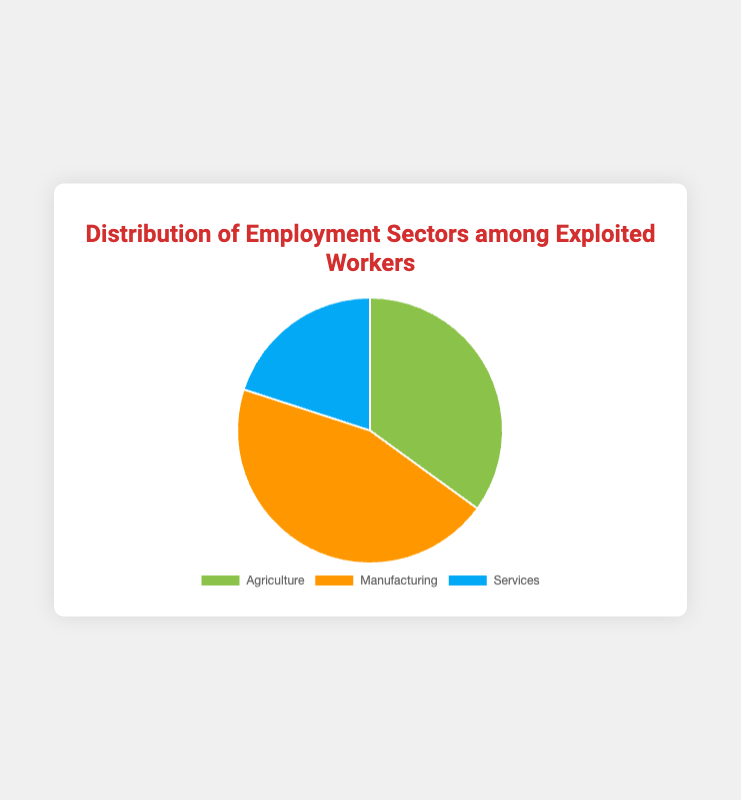What proportion of the workers are in Manufacturing? The pie chart shows 45% of the workers are in the Manufacturing sector.
Answer: 45% How does the proportion of workers in Agriculture compare to those in Services? The chart shows that Agriculture has 35% of workers, whereas Services has 20%. Therefore, Agriculture has 15% more workers than Services.
Answer: Agriculture has 15% more workers than Services What's the combined percentage of workers in Agriculture and Services? The chart shows Agriculture has 35% and Services have 20%. Adding these percentages gives 35% + 20% = 55%.
Answer: 55% Which sector employs the fewest workers? The chart indicates that Services have only 20% of the workers, which is the smallest proportion among the three sectors.
Answer: Services If we combine the percentages of Agriculture and Manufacturing, how does that compare to Services? Agriculture has 35% and Manufacturing has 45%, which adds up to 80%. This is 60% more than the 20% of Services.
Answer: 60% more What color represents the Agriculture sector in the pie chart? The Agriculture sector is represented by the green slice in the chart.
Answer: Green Which sector employs a smaller percentage of workers compared to Agriculture but more compared to Services? The Manufacturing sector has 45%, which is less than Agriculture's 35% but more than Services' 20%.
Answer: Manufacturing What is the difference in employment percentages between the Manufacturing and Services sectors? The Manufacturing sector has 45% of the workers while Services have 20%. The difference is 45% - 20% = 25%.
Answer: 25% If each percentage in the pie chart represents 10 workers, how many workers are in the Manufacturing sector? Each percent represents 10 workers. For the Manufacturing sector, it’s 45% * 10 = 450 workers.
Answer: 450 workers Looking at the colors, which sector has the largest proportion? The largest slice of the pie chart, which is orange, represents the Manufacturing sector at 45%.
Answer: Manufacturing (orange) 